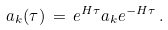<formula> <loc_0><loc_0><loc_500><loc_500>a _ { k } ( \tau ) \, = \, e ^ { H \tau } a _ { k } e ^ { - H \tau } \, .</formula> 